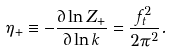<formula> <loc_0><loc_0><loc_500><loc_500>\eta _ { + } \equiv - \frac { \partial \ln Z _ { + } } { \partial \ln k } = \frac { f _ { t } ^ { 2 } } { 2 \pi ^ { 2 } } .</formula> 